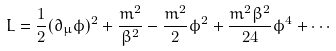Convert formula to latex. <formula><loc_0><loc_0><loc_500><loc_500>L = \frac { 1 } { 2 } ( \partial _ { \mu } \phi ) ^ { 2 } + \frac { m ^ { 2 } } { \beta ^ { 2 } } - \frac { m ^ { 2 } } { 2 } \phi ^ { 2 } + \frac { m ^ { 2 } \beta ^ { 2 } } { 2 4 } \phi ^ { 4 } + \cdots</formula> 